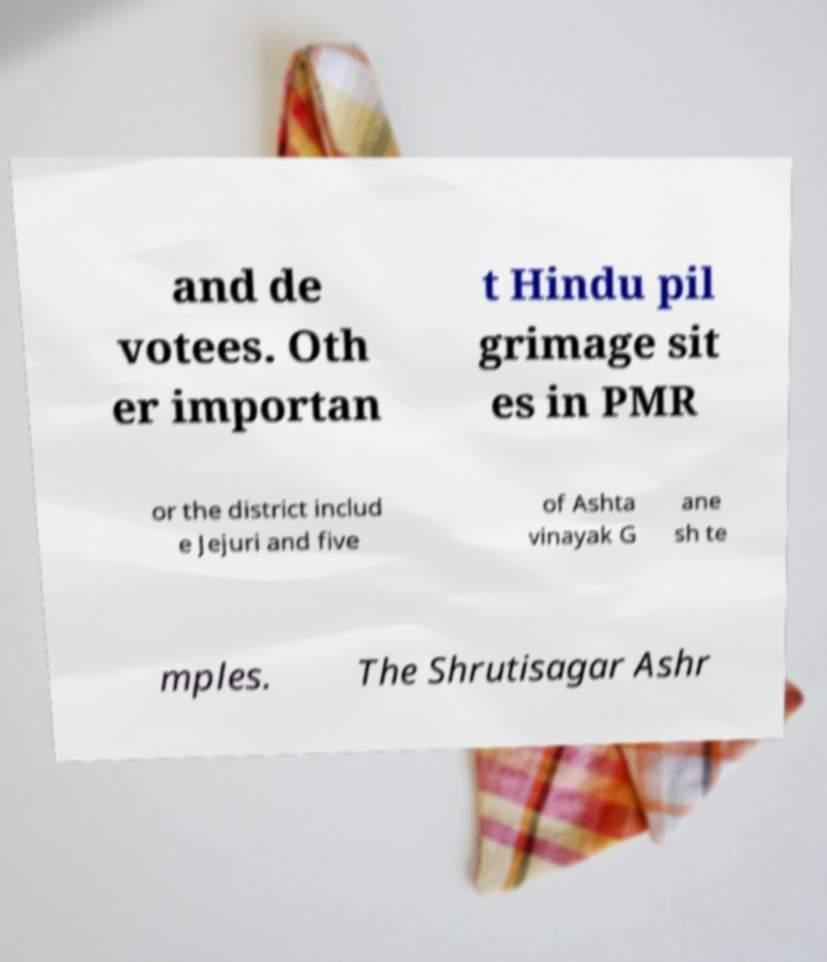Please read and relay the text visible in this image. What does it say? and de votees. Oth er importan t Hindu pil grimage sit es in PMR or the district includ e Jejuri and five of Ashta vinayak G ane sh te mples. The Shrutisagar Ashr 